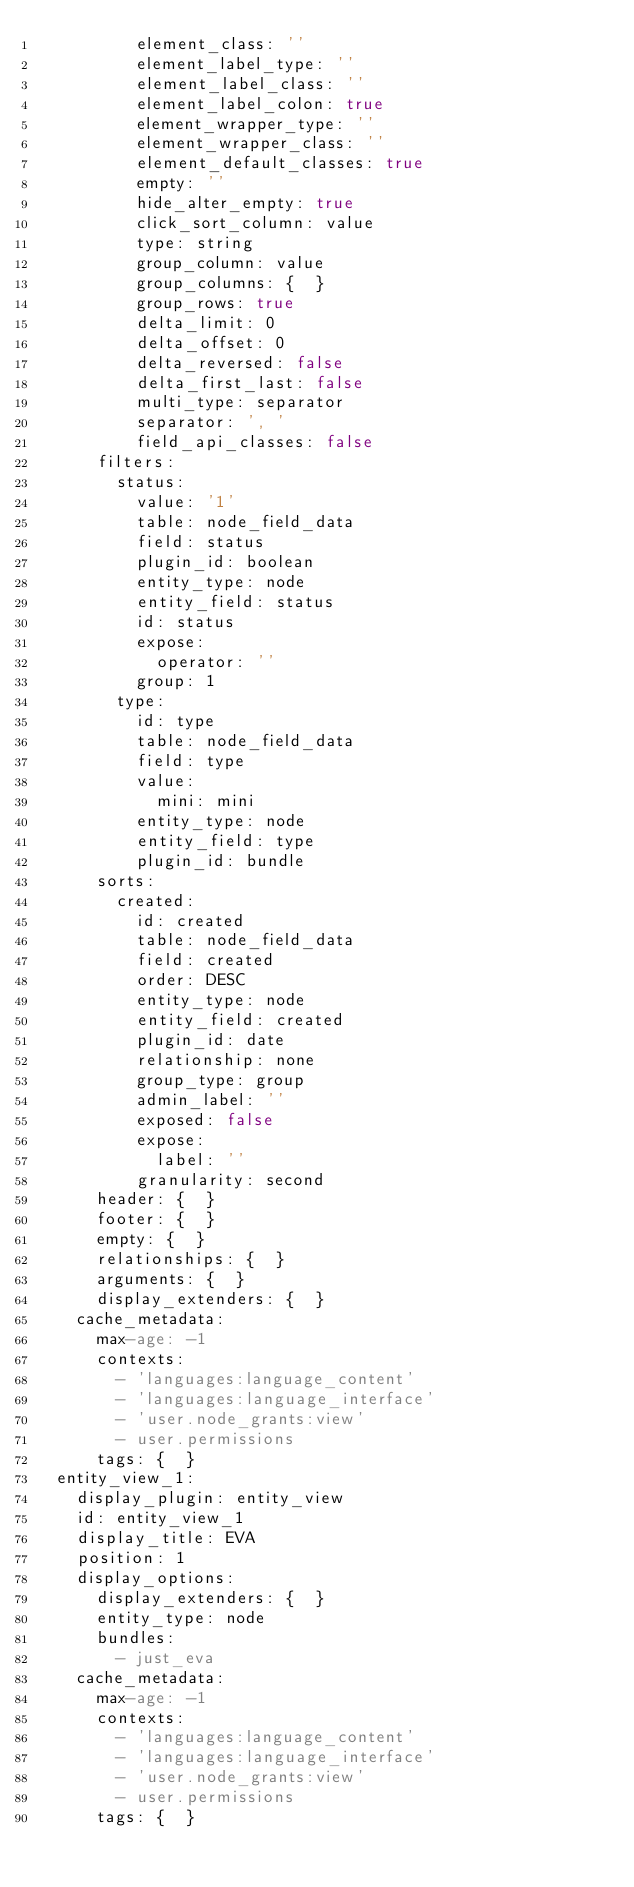Convert code to text. <code><loc_0><loc_0><loc_500><loc_500><_YAML_>          element_class: ''
          element_label_type: ''
          element_label_class: ''
          element_label_colon: true
          element_wrapper_type: ''
          element_wrapper_class: ''
          element_default_classes: true
          empty: ''
          hide_alter_empty: true
          click_sort_column: value
          type: string
          group_column: value
          group_columns: {  }
          group_rows: true
          delta_limit: 0
          delta_offset: 0
          delta_reversed: false
          delta_first_last: false
          multi_type: separator
          separator: ', '
          field_api_classes: false
      filters:
        status:
          value: '1'
          table: node_field_data
          field: status
          plugin_id: boolean
          entity_type: node
          entity_field: status
          id: status
          expose:
            operator: ''
          group: 1
        type:
          id: type
          table: node_field_data
          field: type
          value:
            mini: mini
          entity_type: node
          entity_field: type
          plugin_id: bundle
      sorts:
        created:
          id: created
          table: node_field_data
          field: created
          order: DESC
          entity_type: node
          entity_field: created
          plugin_id: date
          relationship: none
          group_type: group
          admin_label: ''
          exposed: false
          expose:
            label: ''
          granularity: second
      header: {  }
      footer: {  }
      empty: {  }
      relationships: {  }
      arguments: {  }
      display_extenders: {  }
    cache_metadata:
      max-age: -1
      contexts:
        - 'languages:language_content'
        - 'languages:language_interface'
        - 'user.node_grants:view'
        - user.permissions
      tags: {  }
  entity_view_1:
    display_plugin: entity_view
    id: entity_view_1
    display_title: EVA
    position: 1
    display_options:
      display_extenders: {  }
      entity_type: node
      bundles:
        - just_eva
    cache_metadata:
      max-age: -1
      contexts:
        - 'languages:language_content'
        - 'languages:language_interface'
        - 'user.node_grants:view'
        - user.permissions
      tags: {  }
</code> 